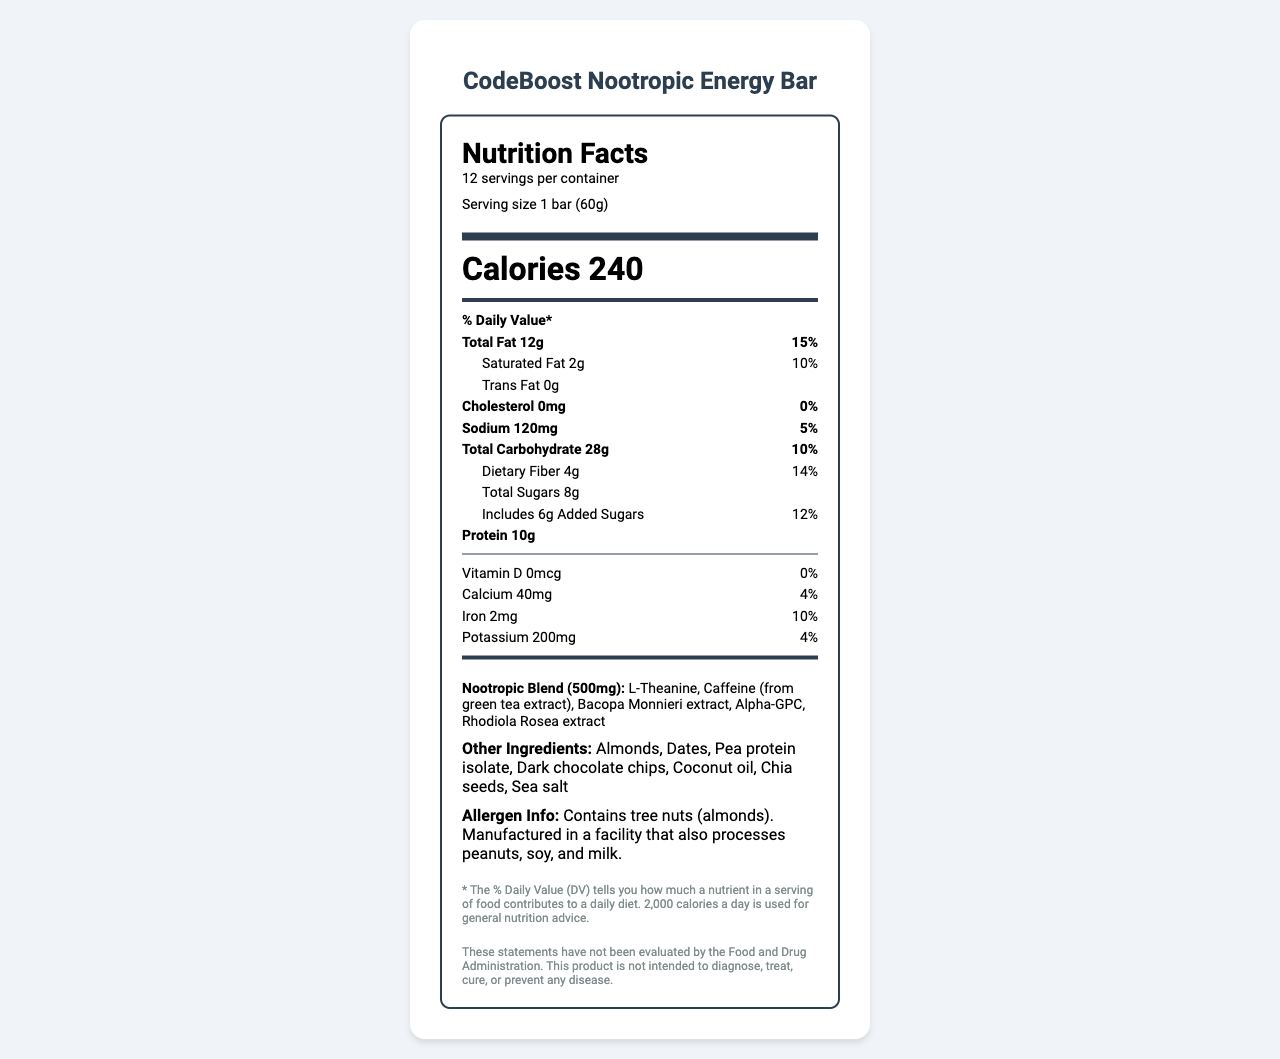who is the manufacturer of the CodeBoost Nootropic Energy Bar? The document explicitly states that TechFuel Nutrition, Inc. is the manufacturer.
Answer: TechFuel Nutrition, Inc. how much protein is in each serving of the bar? The nutrition label shows that each serving of the bar contains 10 grams of protein.
Answer: 10g what is the serving size of the CodeBoost Nootropic Energy Bar? The serving size is noted as 1 bar, which weighs 60 grams.
Answer: 1 bar (60g) how many servings are there per container? The document explicitly states that there are 12 servings per container.
Answer: 12 what are the nootropic ingredients included in the energy bar? The nootropic blend section lists these ingredients as part of the 500mg nootropic blend.
Answer: L-Theanine, Caffeine (from green tea extract), Bacopa Monnieri extract, Alpha-GPC, Rhodiola Rosea extract what is the percentage daily value of total fat in the bar? A. 10% B. 15% C. 20% D. 25% The label shows that the total fat content is 12g, which is 15% of the daily value.
Answer: B. 15% which nutrient has a 0% daily value? A. Cholesterol B. Sodium C. Iron D. Protein The label indicates that cholesterol has a daily value of 0%.
Answer: A. Cholesterol does the bar contain any allergens? The allergen information specifies that the bar contains tree nuts (almonds).
Answer: Yes is the bar high in dietary fiber? The bar contains 4g of dietary fiber, which is 14% of the daily value, often considered substantial.
Answer: Yes describe the main nutritional information of the CodeBoost Nootropic Energy Bar. The document provides comprehensive nutritional details, highlighting the calorie content, macronutrients, vitamin and mineral contributions, and unique cognitive-supporting ingredients.
Answer: The CodeBoost Nootropic Energy Bar provides detailed nutritional information including 240 calories per serving, with 12g of total fat, 2g of saturated fat, and 0g of trans fat. It contains 120mg of sodium, 28g of total carbohydrates including 4g of dietary fiber and 8g of total sugars (6g added sugars), and 10g of protein. It also includes a unique 500mg nootropic blend featuring L-Theanine, Caffeine, Bacopa Monnieri extract, Alpha-GPC, and Rhodiola Rosea extract. what is the expiry date of the bar? The document specifies that the bar is best consumed within 12 months of the production date, but it doesn't provide the actual production or expiry date.
Answer: Not enough information where is the company TechFuel Nutrition, Inc. located? The address for TechFuel Nutrition, Inc. is clearly mentioned in the document.
Answer: 123 Innovation Way, Silicon Valley, CA 94025 